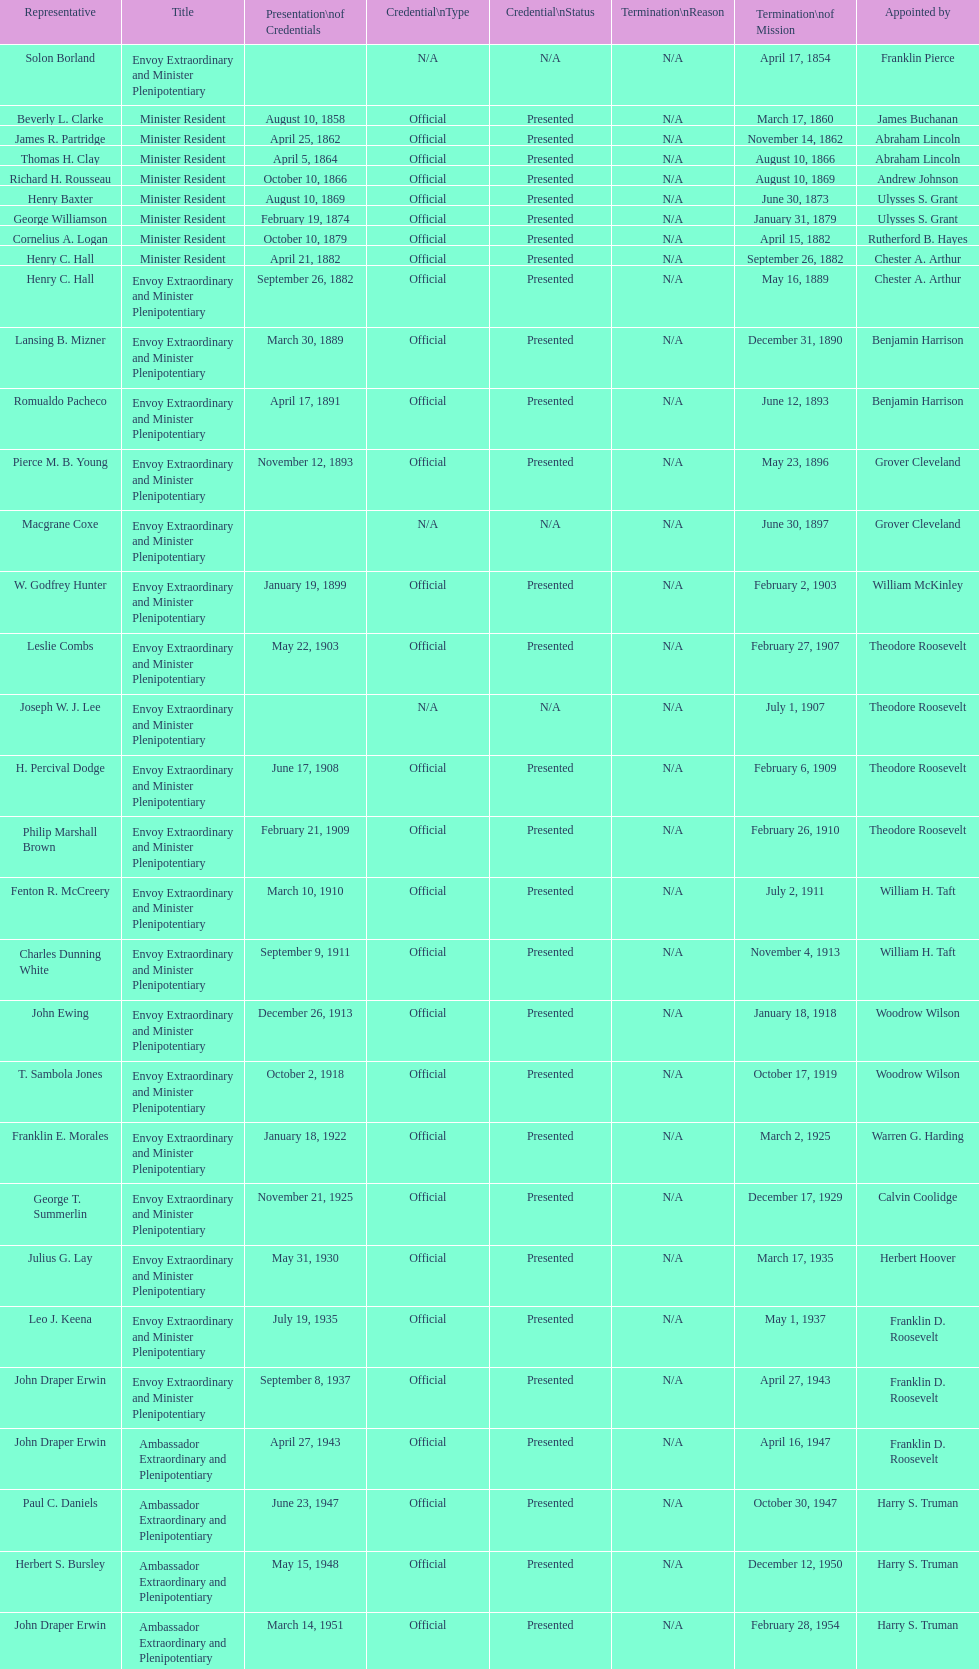How many total representatives have there been? 50. 